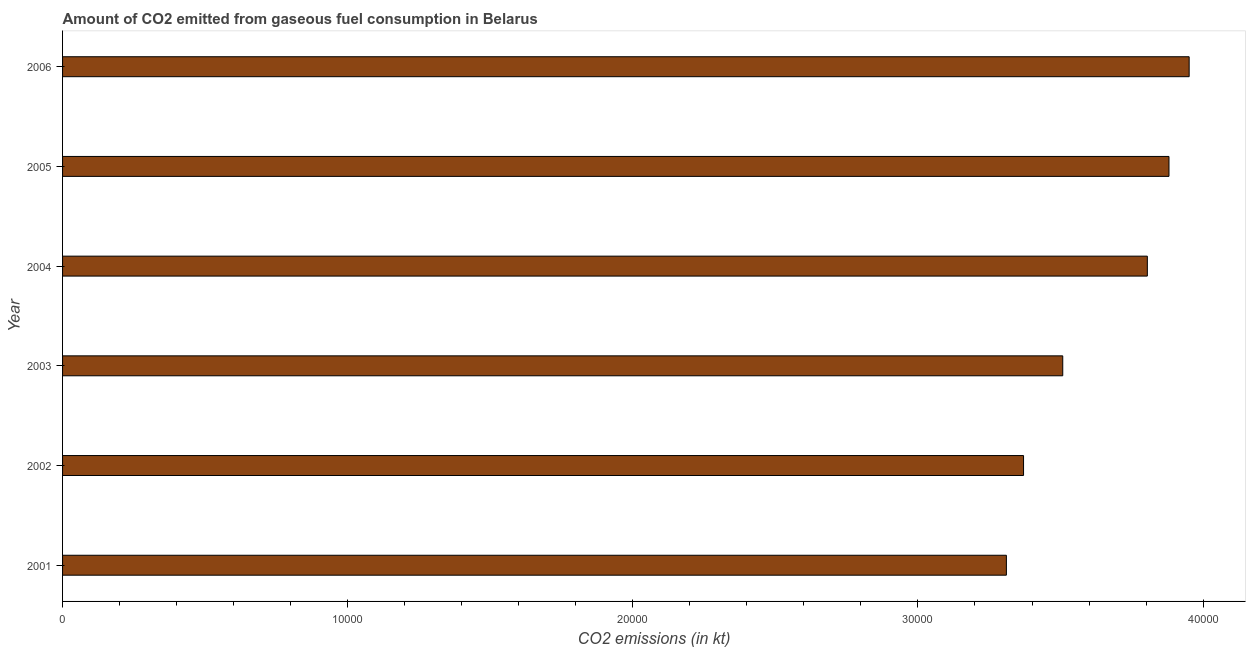Does the graph contain any zero values?
Make the answer very short. No. What is the title of the graph?
Give a very brief answer. Amount of CO2 emitted from gaseous fuel consumption in Belarus. What is the label or title of the X-axis?
Give a very brief answer. CO2 emissions (in kt). What is the co2 emissions from gaseous fuel consumption in 2003?
Give a very brief answer. 3.51e+04. Across all years, what is the maximum co2 emissions from gaseous fuel consumption?
Keep it short and to the point. 3.95e+04. Across all years, what is the minimum co2 emissions from gaseous fuel consumption?
Provide a short and direct response. 3.31e+04. In which year was the co2 emissions from gaseous fuel consumption maximum?
Ensure brevity in your answer.  2006. In which year was the co2 emissions from gaseous fuel consumption minimum?
Ensure brevity in your answer.  2001. What is the sum of the co2 emissions from gaseous fuel consumption?
Keep it short and to the point. 2.18e+05. What is the difference between the co2 emissions from gaseous fuel consumption in 2001 and 2004?
Ensure brevity in your answer.  -4943.12. What is the average co2 emissions from gaseous fuel consumption per year?
Your answer should be compact. 3.64e+04. What is the median co2 emissions from gaseous fuel consumption?
Your response must be concise. 3.66e+04. In how many years, is the co2 emissions from gaseous fuel consumption greater than 14000 kt?
Give a very brief answer. 6. Do a majority of the years between 2004 and 2005 (inclusive) have co2 emissions from gaseous fuel consumption greater than 14000 kt?
Provide a succinct answer. Yes. What is the ratio of the co2 emissions from gaseous fuel consumption in 2002 to that in 2005?
Provide a succinct answer. 0.87. What is the difference between the highest and the second highest co2 emissions from gaseous fuel consumption?
Ensure brevity in your answer.  707.73. What is the difference between the highest and the lowest co2 emissions from gaseous fuel consumption?
Ensure brevity in your answer.  6409.92. In how many years, is the co2 emissions from gaseous fuel consumption greater than the average co2 emissions from gaseous fuel consumption taken over all years?
Your answer should be compact. 3. Are all the bars in the graph horizontal?
Make the answer very short. Yes. How many years are there in the graph?
Keep it short and to the point. 6. Are the values on the major ticks of X-axis written in scientific E-notation?
Offer a terse response. No. What is the CO2 emissions (in kt) in 2001?
Offer a very short reply. 3.31e+04. What is the CO2 emissions (in kt) in 2002?
Offer a terse response. 3.37e+04. What is the CO2 emissions (in kt) in 2003?
Your response must be concise. 3.51e+04. What is the CO2 emissions (in kt) in 2004?
Ensure brevity in your answer.  3.80e+04. What is the CO2 emissions (in kt) of 2005?
Make the answer very short. 3.88e+04. What is the CO2 emissions (in kt) of 2006?
Offer a terse response. 3.95e+04. What is the difference between the CO2 emissions (in kt) in 2001 and 2002?
Provide a succinct answer. -601.39. What is the difference between the CO2 emissions (in kt) in 2001 and 2003?
Make the answer very short. -1976.51. What is the difference between the CO2 emissions (in kt) in 2001 and 2004?
Ensure brevity in your answer.  -4943.12. What is the difference between the CO2 emissions (in kt) in 2001 and 2005?
Provide a short and direct response. -5702.19. What is the difference between the CO2 emissions (in kt) in 2001 and 2006?
Offer a terse response. -6409.92. What is the difference between the CO2 emissions (in kt) in 2002 and 2003?
Your answer should be compact. -1375.12. What is the difference between the CO2 emissions (in kt) in 2002 and 2004?
Provide a succinct answer. -4341.73. What is the difference between the CO2 emissions (in kt) in 2002 and 2005?
Offer a very short reply. -5100.8. What is the difference between the CO2 emissions (in kt) in 2002 and 2006?
Your answer should be compact. -5808.53. What is the difference between the CO2 emissions (in kt) in 2003 and 2004?
Give a very brief answer. -2966.6. What is the difference between the CO2 emissions (in kt) in 2003 and 2005?
Keep it short and to the point. -3725.67. What is the difference between the CO2 emissions (in kt) in 2003 and 2006?
Your answer should be compact. -4433.4. What is the difference between the CO2 emissions (in kt) in 2004 and 2005?
Keep it short and to the point. -759.07. What is the difference between the CO2 emissions (in kt) in 2004 and 2006?
Keep it short and to the point. -1466.8. What is the difference between the CO2 emissions (in kt) in 2005 and 2006?
Your answer should be compact. -707.73. What is the ratio of the CO2 emissions (in kt) in 2001 to that in 2002?
Provide a succinct answer. 0.98. What is the ratio of the CO2 emissions (in kt) in 2001 to that in 2003?
Offer a very short reply. 0.94. What is the ratio of the CO2 emissions (in kt) in 2001 to that in 2004?
Provide a succinct answer. 0.87. What is the ratio of the CO2 emissions (in kt) in 2001 to that in 2005?
Your answer should be compact. 0.85. What is the ratio of the CO2 emissions (in kt) in 2001 to that in 2006?
Offer a terse response. 0.84. What is the ratio of the CO2 emissions (in kt) in 2002 to that in 2003?
Your response must be concise. 0.96. What is the ratio of the CO2 emissions (in kt) in 2002 to that in 2004?
Provide a short and direct response. 0.89. What is the ratio of the CO2 emissions (in kt) in 2002 to that in 2005?
Your answer should be very brief. 0.87. What is the ratio of the CO2 emissions (in kt) in 2002 to that in 2006?
Keep it short and to the point. 0.85. What is the ratio of the CO2 emissions (in kt) in 2003 to that in 2004?
Provide a succinct answer. 0.92. What is the ratio of the CO2 emissions (in kt) in 2003 to that in 2005?
Ensure brevity in your answer.  0.9. What is the ratio of the CO2 emissions (in kt) in 2003 to that in 2006?
Offer a terse response. 0.89. 